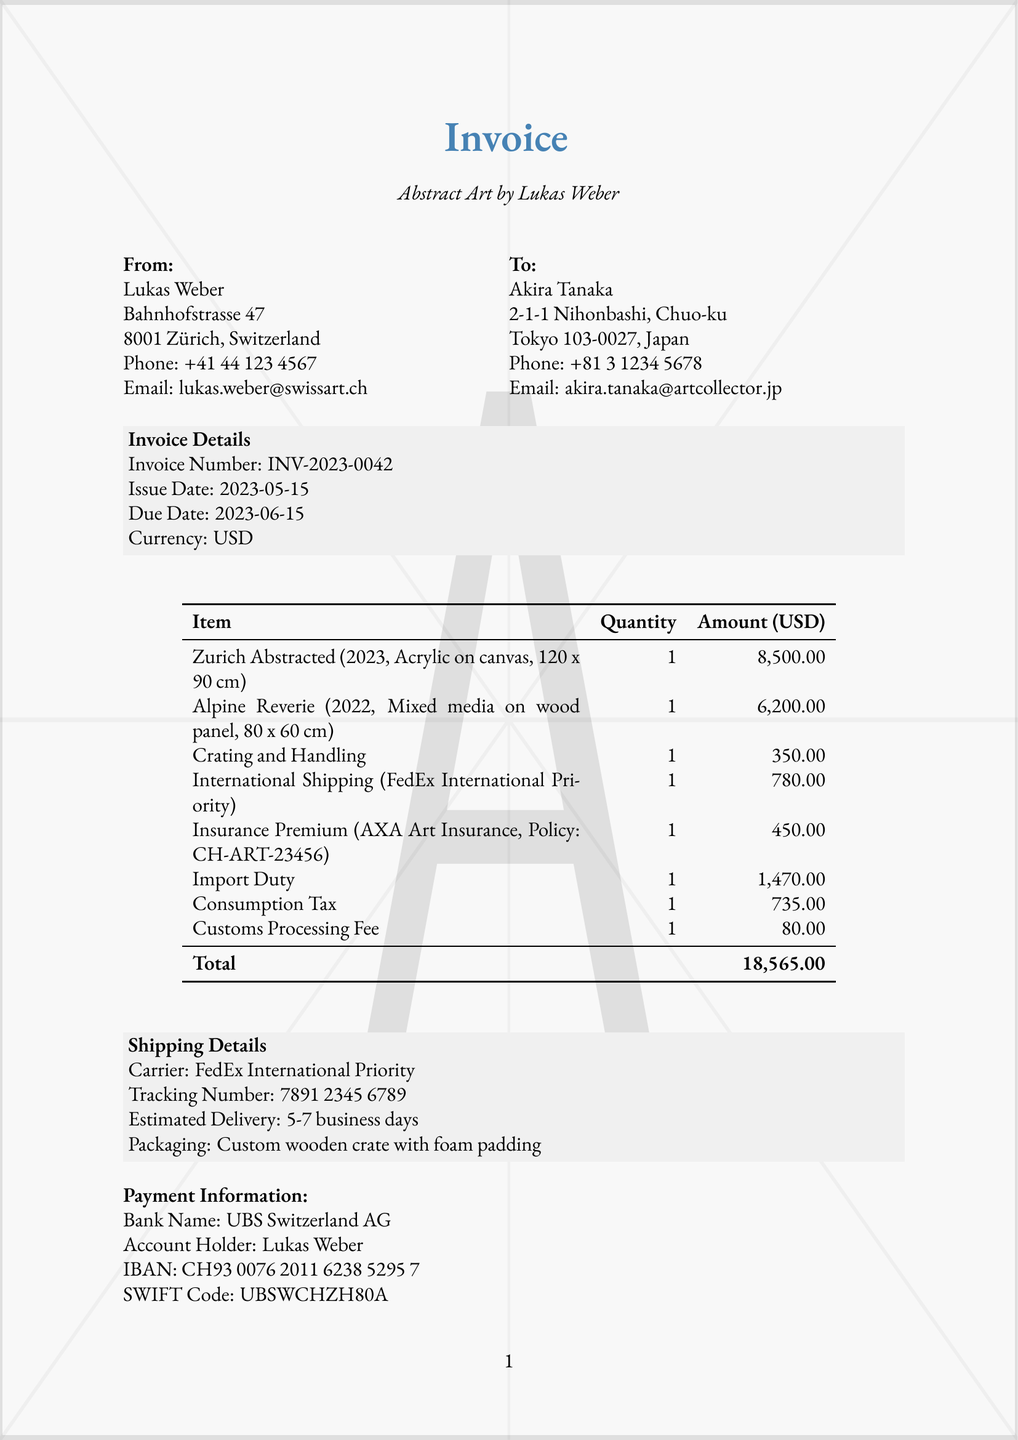What is the name of the artist? The document specifies the name of the artist as Lukas Weber.
Answer: Lukas Weber What is the total amount due? The total amount due is listed at the bottom of the invoice table, summing all charges.
Answer: 18,565.00 What is the tracking number for the shipment? The tracking number for the shipment is provided in the shipping details section of the invoice.
Answer: 7891 2345 6789 What is the insurance provider's name? The document contains the name of the insurance provider under the insurance section.
Answer: AXA Art Insurance How many artworks were listed in the invoice? There are two artworks mentioned in the artwork details section.
Answer: 2 What is the estimated delivery time for the artwork? The estimated delivery time is given in the shipping details section of the invoice.
Answer: 5-7 business days What is the import duty charged? The import duty amount can be found in the customs fees section of the invoice.
Answer: 1,470.00 When is the due date for payment? The due date for payment is specified in the invoice details section of the document.
Answer: 2023-06-15 What is the packaging used for shipping? The packaging details for shipping are provided in the shipping details section.
Answer: Custom wooden crate with foam padding 